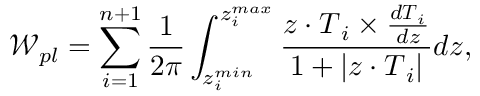<formula> <loc_0><loc_0><loc_500><loc_500>\mathcal { W } _ { p l } = \sum _ { i = 1 } ^ { n + 1 } \frac { 1 } { 2 \pi } \int _ { z _ { i } ^ { \min } } ^ { z _ { i } ^ { \max } } \frac { z \cdot T _ { i } \times \frac { d T _ { i } } { d z } } { 1 + | z \cdot T _ { i } | } d z ,</formula> 